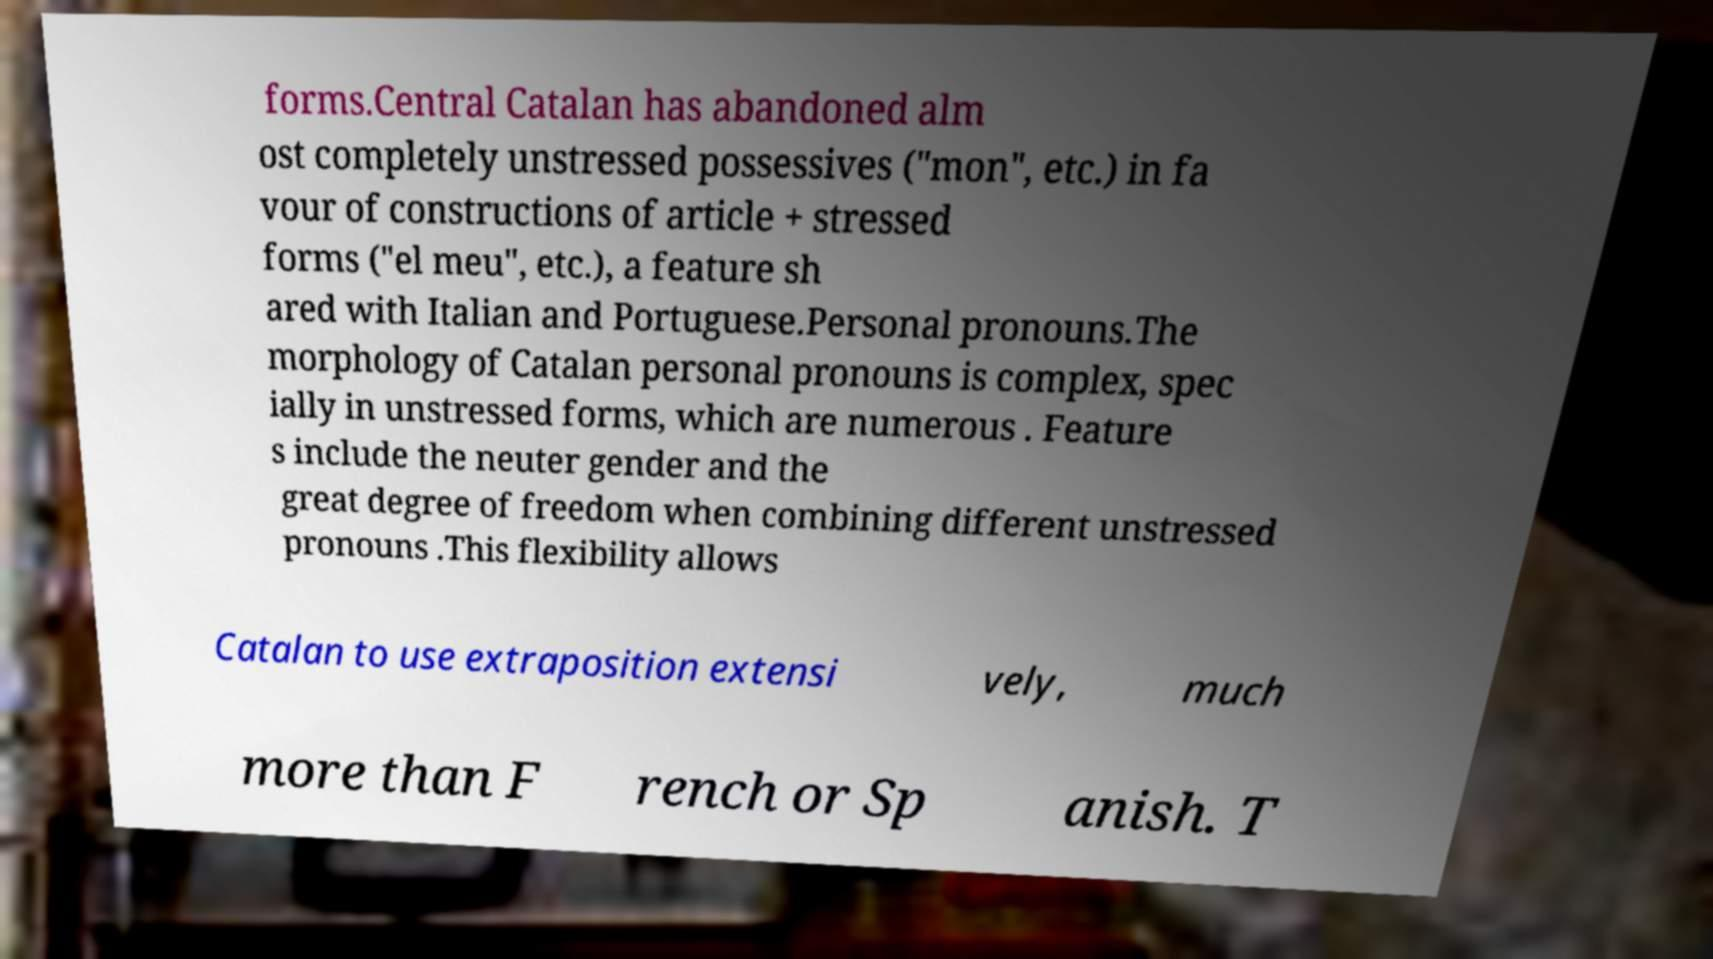What messages or text are displayed in this image? I need them in a readable, typed format. forms.Central Catalan has abandoned alm ost completely unstressed possessives ("mon", etc.) in fa vour of constructions of article + stressed forms ("el meu", etc.), a feature sh ared with Italian and Portuguese.Personal pronouns.The morphology of Catalan personal pronouns is complex, spec ially in unstressed forms, which are numerous . Feature s include the neuter gender and the great degree of freedom when combining different unstressed pronouns .This flexibility allows Catalan to use extraposition extensi vely, much more than F rench or Sp anish. T 